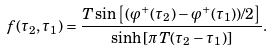Convert formula to latex. <formula><loc_0><loc_0><loc_500><loc_500>f ( \tau _ { 2 } , \tau _ { 1 } ) = \frac { T \sin \left [ ( \varphi ^ { + } ( \tau _ { 2 } ) - \varphi ^ { + } ( \tau _ { 1 } ) ) / 2 \right ] } { \sinh \left [ \pi T ( \tau _ { 2 } - \tau _ { 1 } ) \right ] } .</formula> 